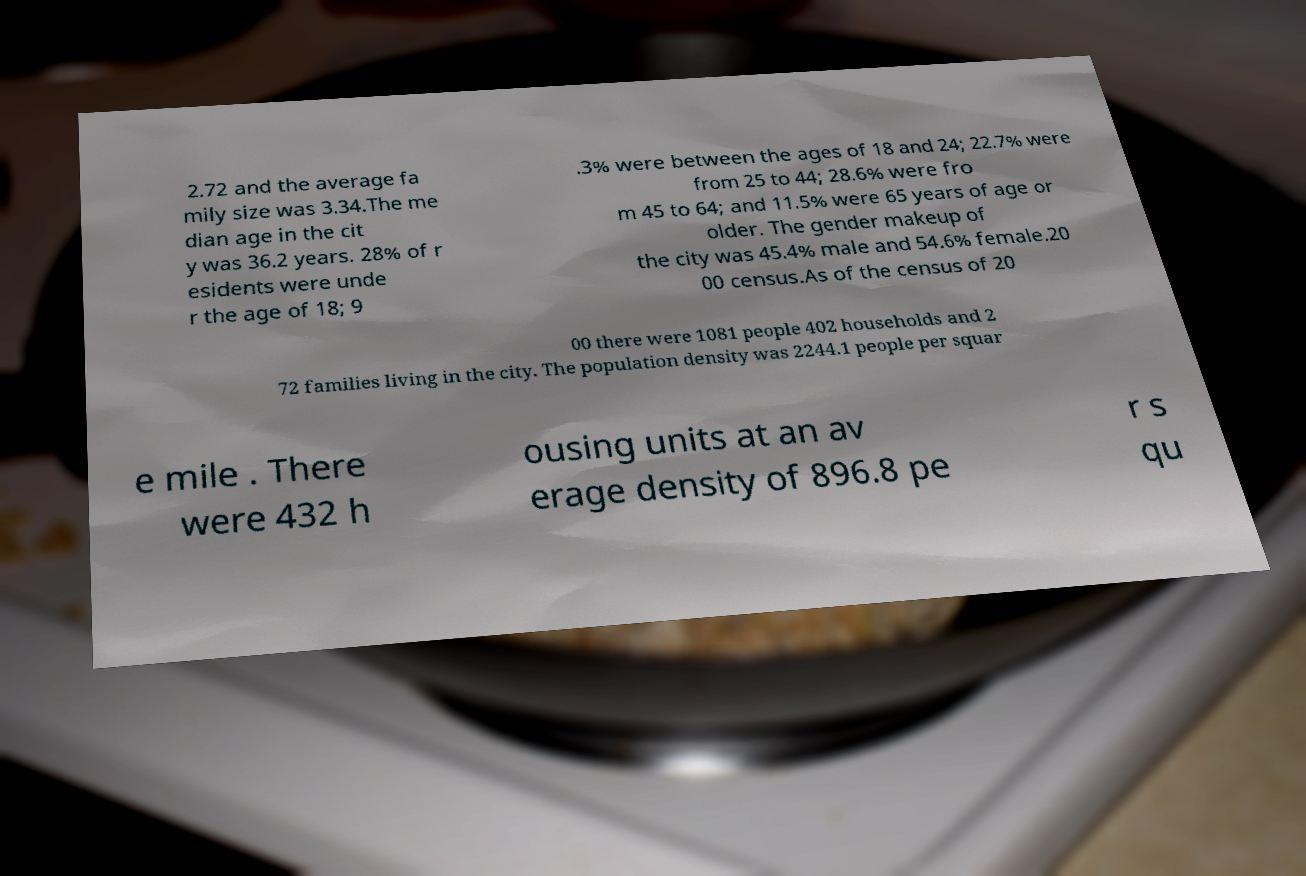What messages or text are displayed in this image? I need them in a readable, typed format. 2.72 and the average fa mily size was 3.34.The me dian age in the cit y was 36.2 years. 28% of r esidents were unde r the age of 18; 9 .3% were between the ages of 18 and 24; 22.7% were from 25 to 44; 28.6% were fro m 45 to 64; and 11.5% were 65 years of age or older. The gender makeup of the city was 45.4% male and 54.6% female.20 00 census.As of the census of 20 00 there were 1081 people 402 households and 2 72 families living in the city. The population density was 2244.1 people per squar e mile . There were 432 h ousing units at an av erage density of 896.8 pe r s qu 